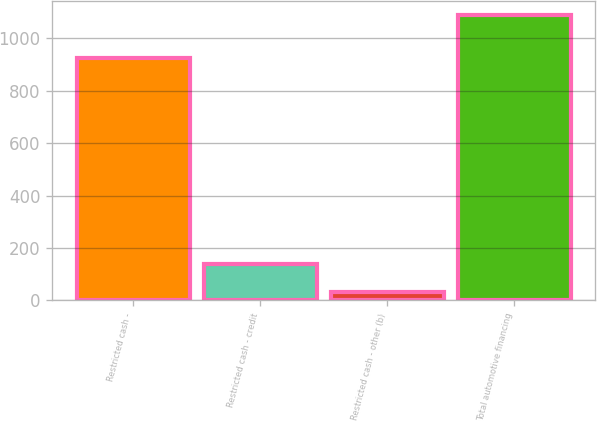<chart> <loc_0><loc_0><loc_500><loc_500><bar_chart><fcel>Restricted cash -<fcel>Restricted cash - credit<fcel>Restricted cash - other (b)<fcel>Total automotive financing<nl><fcel>926<fcel>138.7<fcel>33<fcel>1090<nl></chart> 